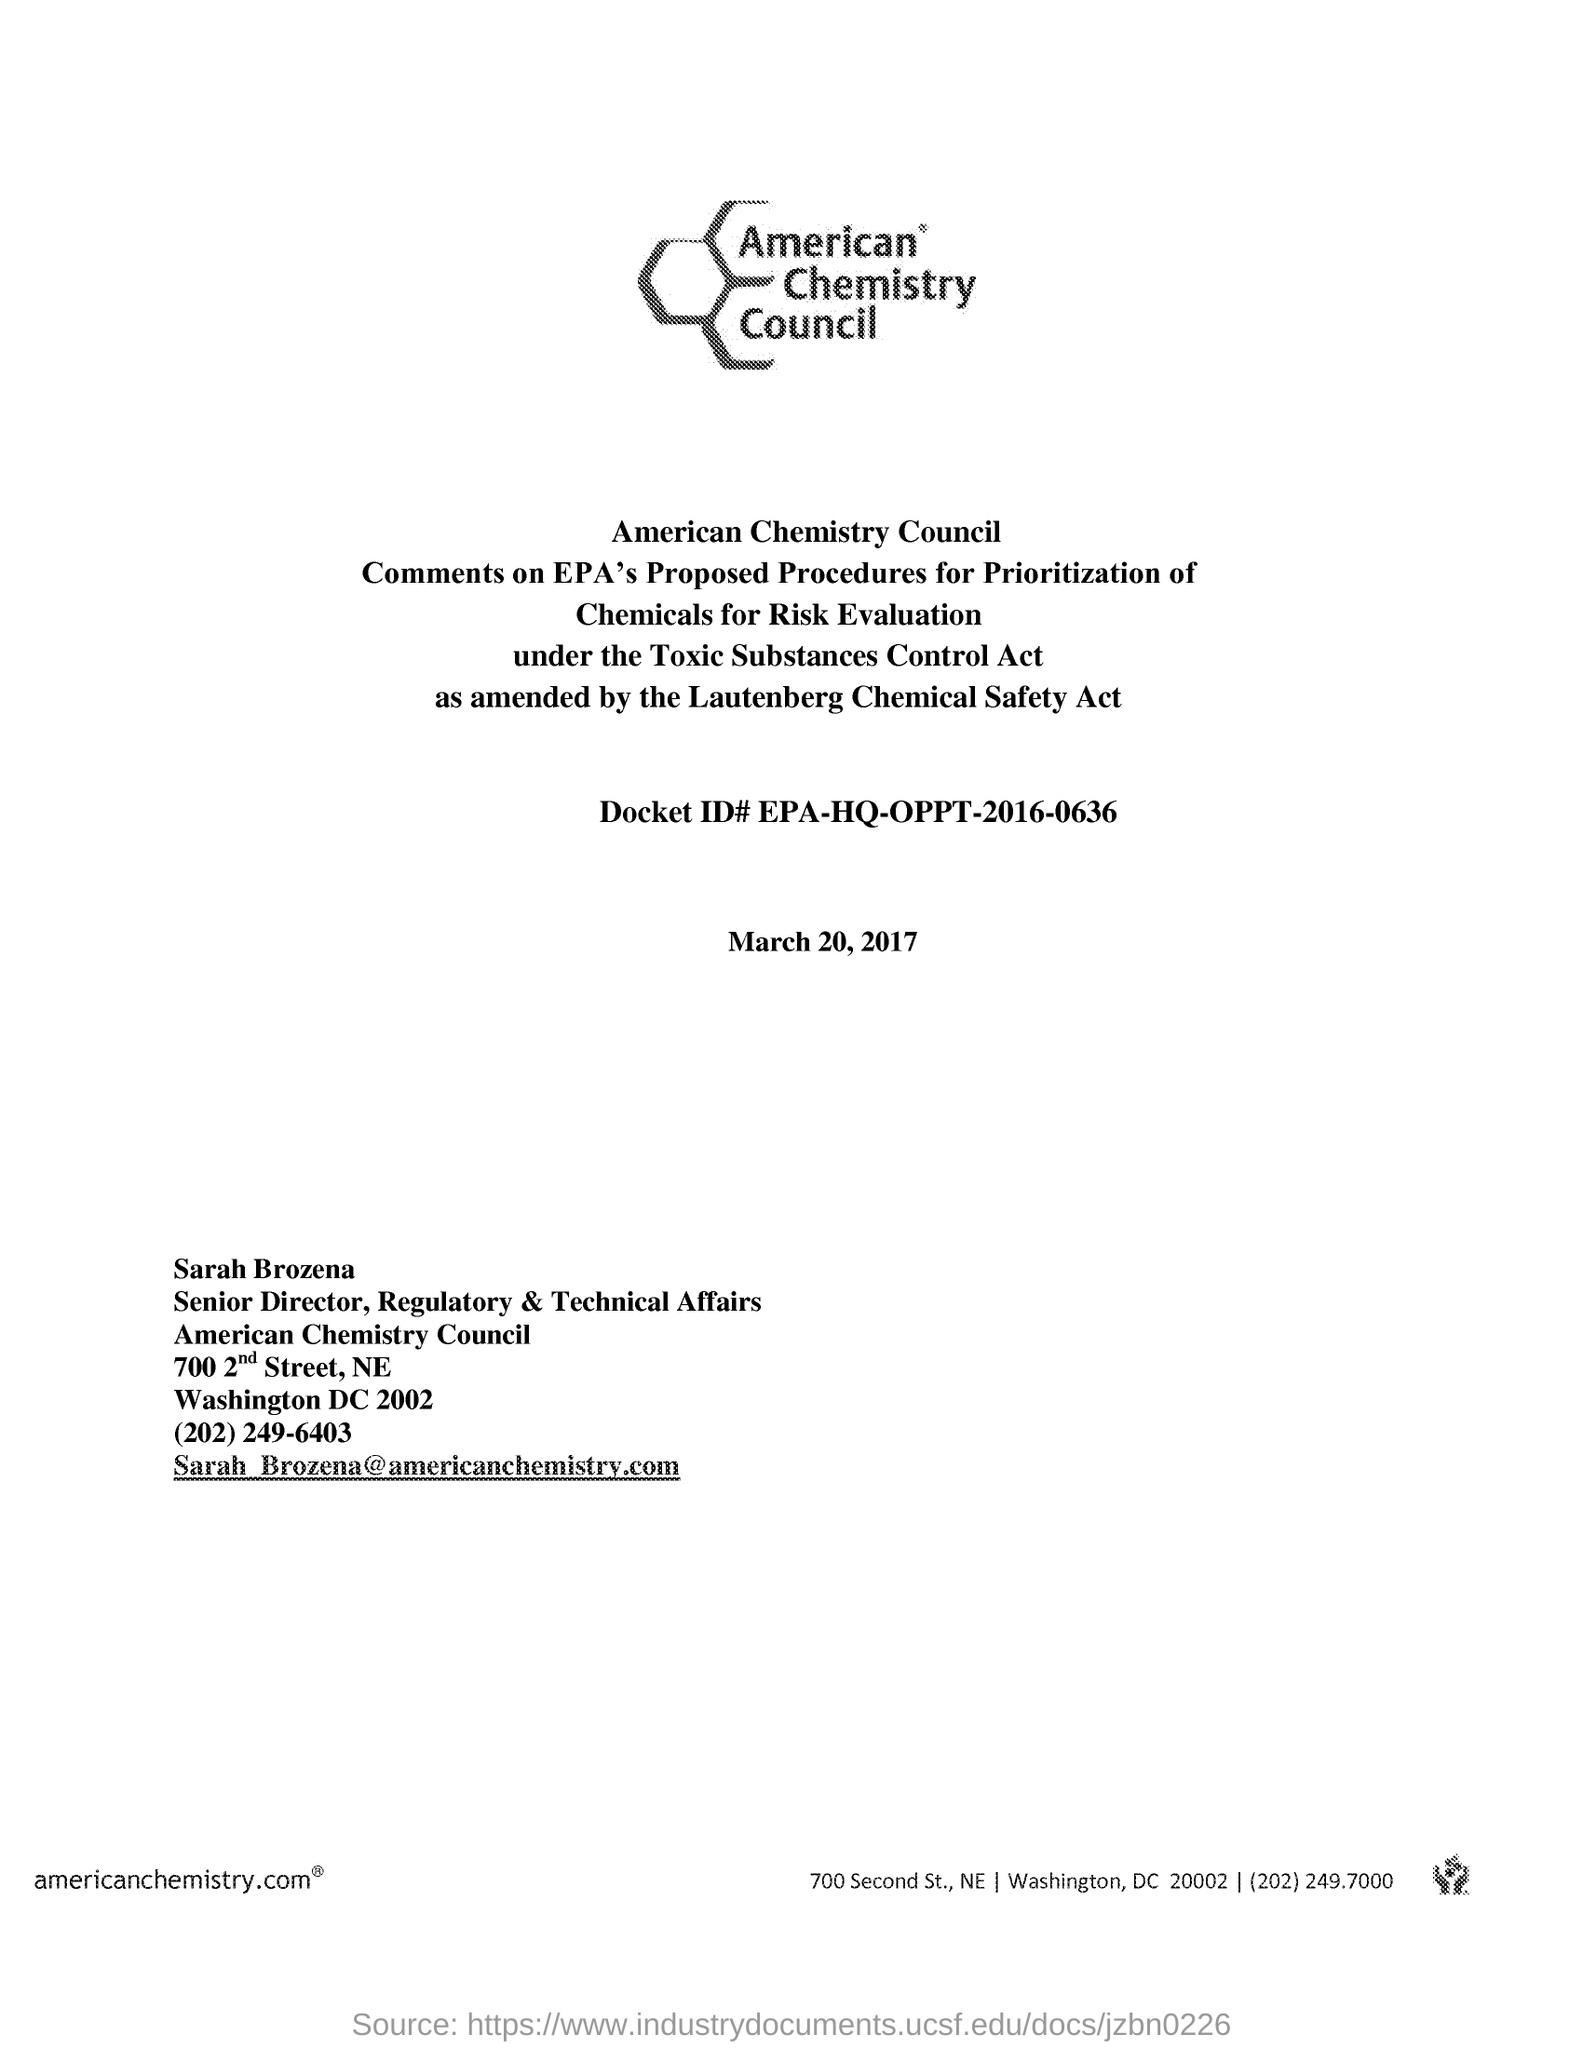What email is provided at the bottom?
Give a very brief answer. Sarah_brozena@americanchemistry.com. What is the date on the document?
Your answer should be compact. March 20, 2017. What is Sarah Brozena's designation in american chemistry council?
Your answer should be very brief. Senior director, regulatory and technical affairs. Who is the Senior director, regulatory and technical affairs at American chemistry council?
Provide a succinct answer. Sarah Brozena. 